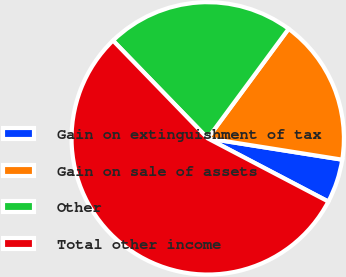Convert chart. <chart><loc_0><loc_0><loc_500><loc_500><pie_chart><fcel>Gain on extinguishment of tax<fcel>Gain on sale of assets<fcel>Other<fcel>Total other income<nl><fcel>5.18%<fcel>17.38%<fcel>22.37%<fcel>55.08%<nl></chart> 